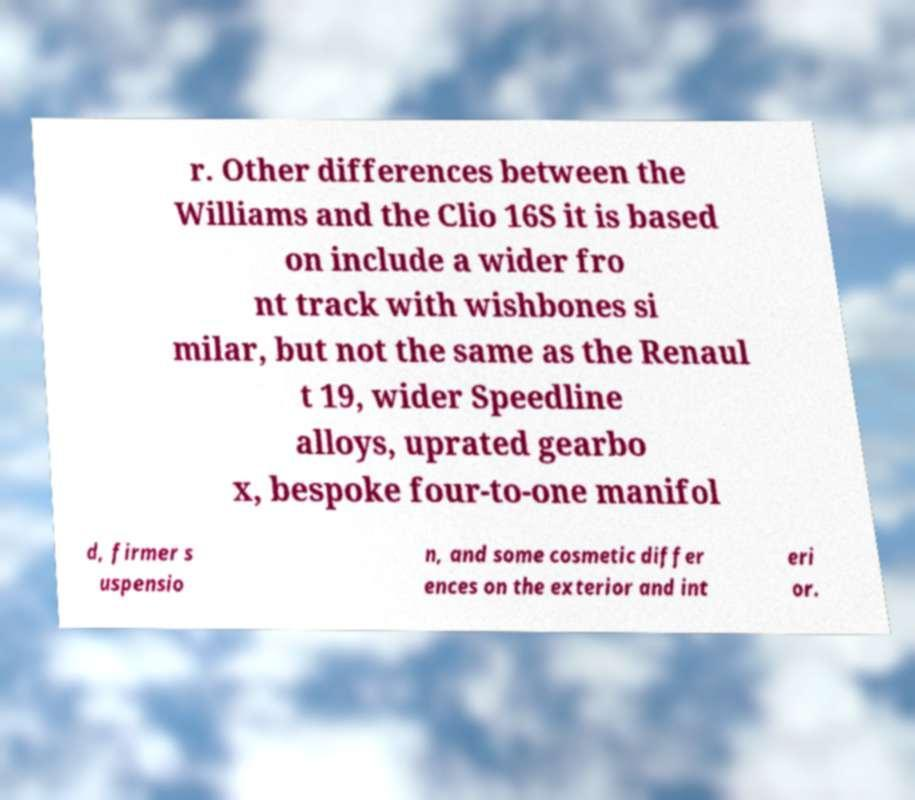Please identify and transcribe the text found in this image. r. Other differences between the Williams and the Clio 16S it is based on include a wider fro nt track with wishbones si milar, but not the same as the Renaul t 19, wider Speedline alloys, uprated gearbo x, bespoke four-to-one manifol d, firmer s uspensio n, and some cosmetic differ ences on the exterior and int eri or. 